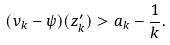Convert formula to latex. <formula><loc_0><loc_0><loc_500><loc_500>( v _ { k } - \psi ) ( z ^ { \prime } _ { k } ) > a _ { k } - \frac { 1 } { k } .</formula> 